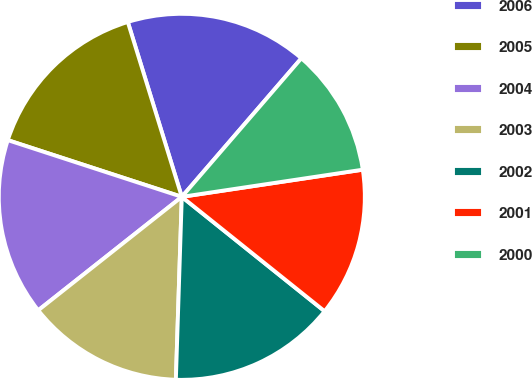Convert chart. <chart><loc_0><loc_0><loc_500><loc_500><pie_chart><fcel>2006<fcel>2005<fcel>2004<fcel>2003<fcel>2002<fcel>2001<fcel>2000<nl><fcel>16.1%<fcel>15.22%<fcel>15.66%<fcel>13.84%<fcel>14.77%<fcel>13.12%<fcel>11.3%<nl></chart> 